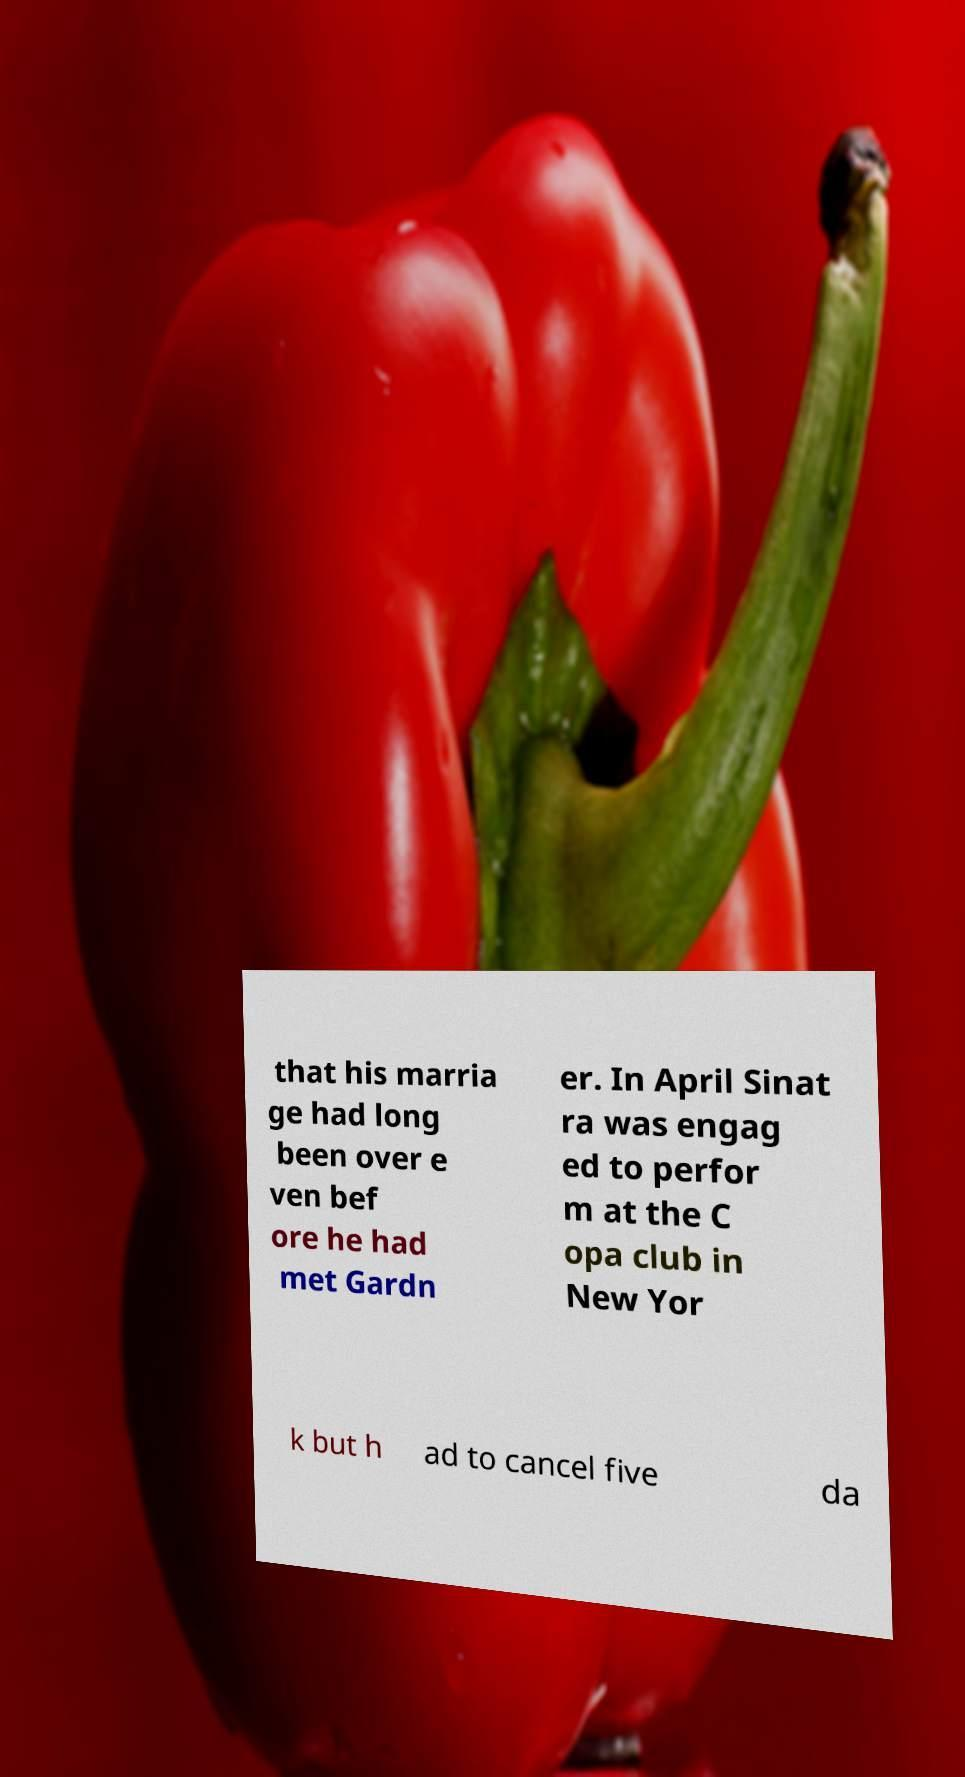Could you assist in decoding the text presented in this image and type it out clearly? that his marria ge had long been over e ven bef ore he had met Gardn er. In April Sinat ra was engag ed to perfor m at the C opa club in New Yor k but h ad to cancel five da 